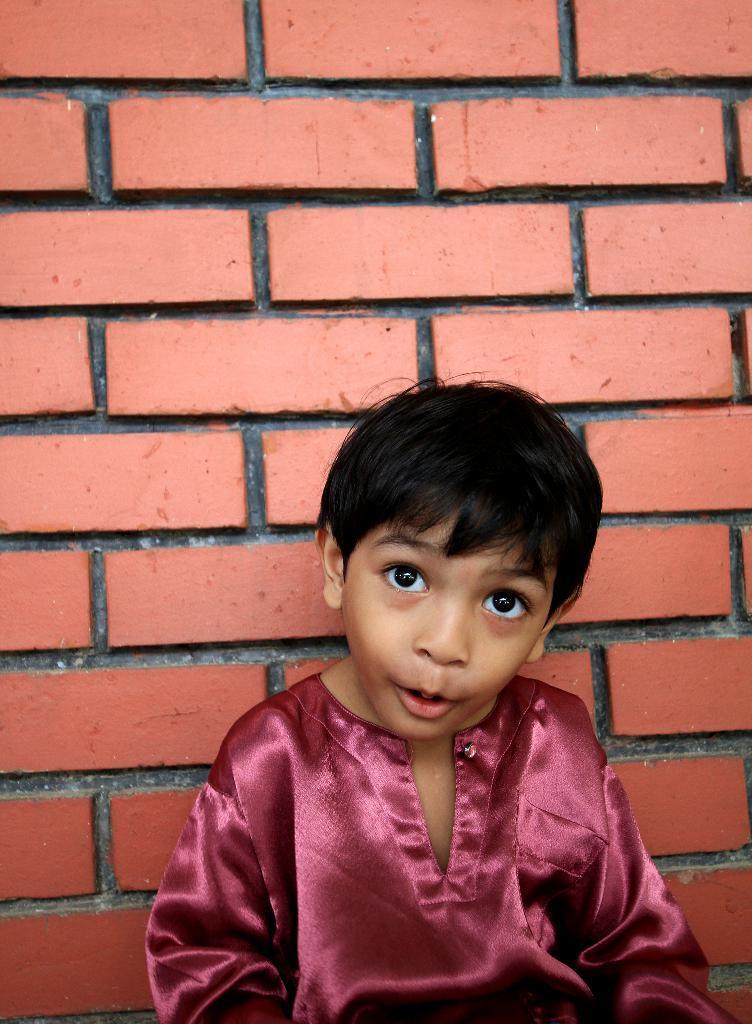Could you give a brief overview of what you see in this image? In this image there is a boy visible in front of the wall. 